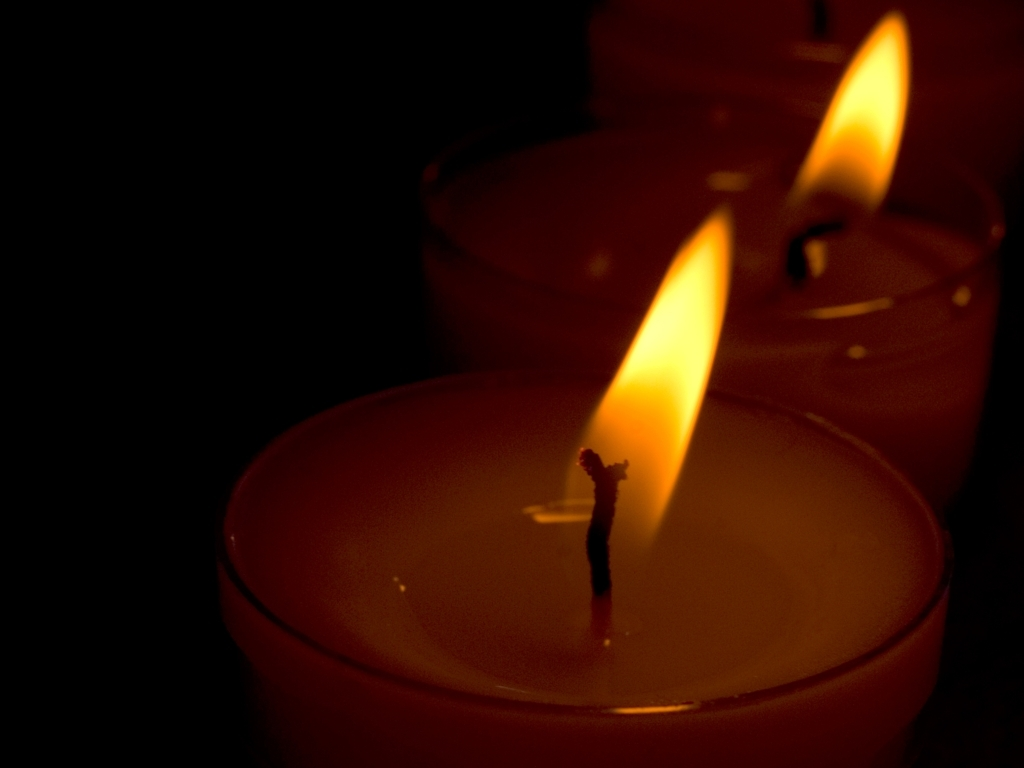Is the quality of the picture excellent? While the notion of 'excellent' quality can be subjective, the picture demonstrates a specific aesthetic by capturing the soothing ambiance created by the candlelight. The focus is sharp on the nearest flame, allowing one to see the details of the wick and the melted wax. However, the darker background and soft lighting conditions might not satisfy criteria for 'excellent' quality in a technical photography sense because details are lost in shadows. 